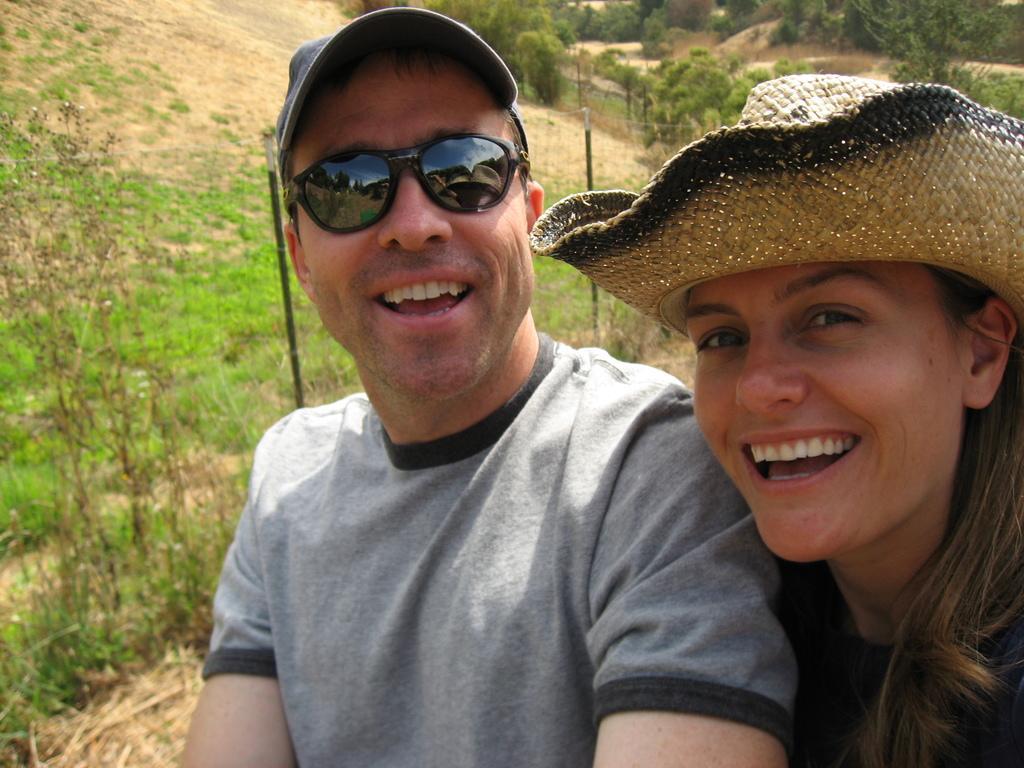In one or two sentences, can you explain what this image depicts? In this there is a lady and a man standing wearing hats men is wearing glasses, in the background there are trees and grassland. 